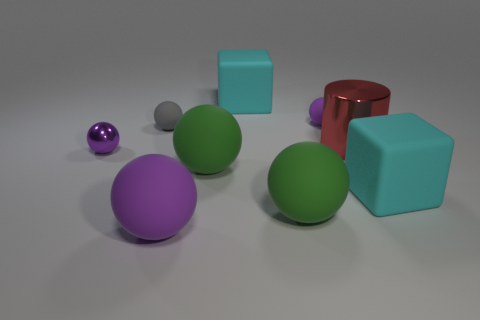Subtract all cyan cubes. How many were subtracted if there are1cyan cubes left? 1 Subtract all blue blocks. How many purple balls are left? 3 Subtract all green balls. How many balls are left? 4 Subtract all small purple shiny spheres. How many spheres are left? 5 Subtract all brown balls. Subtract all purple cylinders. How many balls are left? 6 Subtract all spheres. How many objects are left? 3 Add 9 purple metal spheres. How many purple metal spheres are left? 10 Add 8 big green spheres. How many big green spheres exist? 10 Subtract 1 red cylinders. How many objects are left? 8 Subtract all large green spheres. Subtract all gray matte balls. How many objects are left? 6 